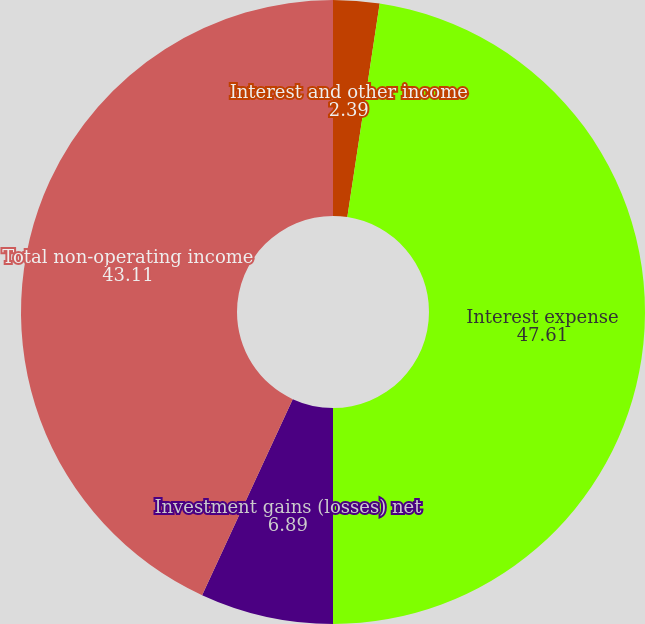<chart> <loc_0><loc_0><loc_500><loc_500><pie_chart><fcel>Interest and other income<fcel>Interest expense<fcel>Investment gains (losses) net<fcel>Total non-operating income<nl><fcel>2.39%<fcel>47.61%<fcel>6.89%<fcel>43.11%<nl></chart> 